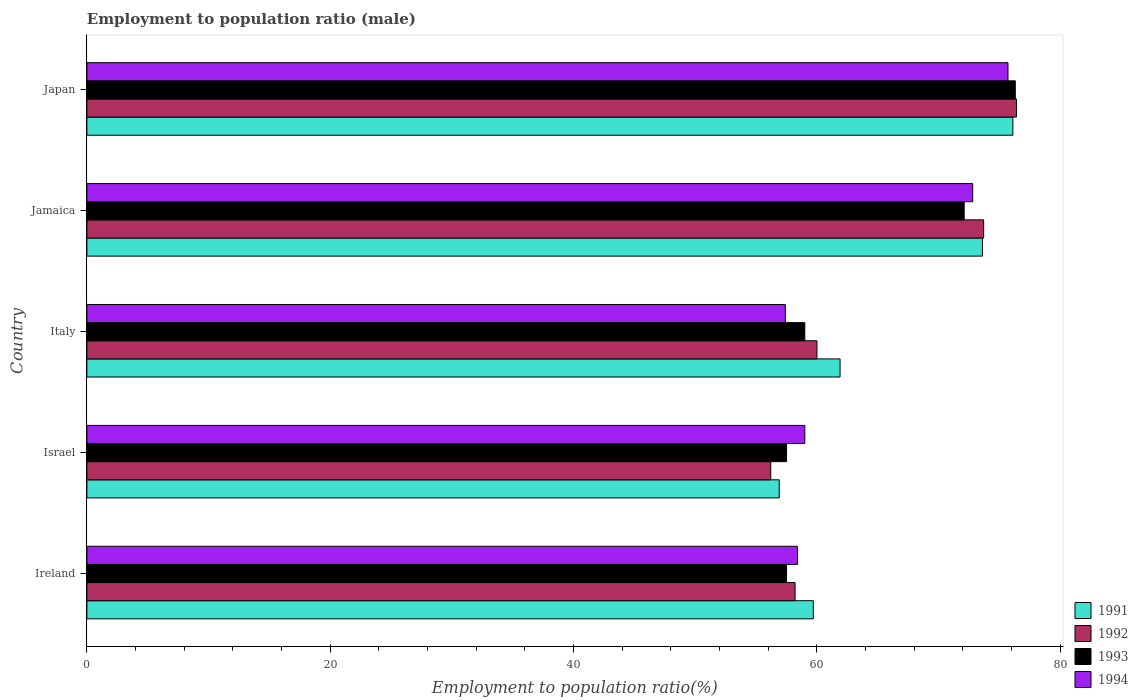How many different coloured bars are there?
Your answer should be compact. 4. How many groups of bars are there?
Offer a very short reply. 5. Are the number of bars on each tick of the Y-axis equal?
Give a very brief answer. Yes. What is the label of the 2nd group of bars from the top?
Provide a succinct answer. Jamaica. What is the employment to population ratio in 1991 in Ireland?
Provide a short and direct response. 59.7. Across all countries, what is the maximum employment to population ratio in 1994?
Offer a terse response. 75.7. Across all countries, what is the minimum employment to population ratio in 1992?
Your response must be concise. 56.2. In which country was the employment to population ratio in 1991 maximum?
Provide a short and direct response. Japan. What is the total employment to population ratio in 1992 in the graph?
Provide a succinct answer. 324.5. What is the difference between the employment to population ratio in 1991 in Ireland and that in Japan?
Your answer should be compact. -16.4. What is the average employment to population ratio in 1993 per country?
Keep it short and to the point. 64.48. What is the difference between the employment to population ratio in 1992 and employment to population ratio in 1993 in Jamaica?
Your response must be concise. 1.6. What is the ratio of the employment to population ratio in 1993 in Israel to that in Italy?
Your response must be concise. 0.97. What is the difference between the highest and the second highest employment to population ratio in 1993?
Give a very brief answer. 4.2. What is the difference between the highest and the lowest employment to population ratio in 1993?
Your answer should be compact. 18.8. Is it the case that in every country, the sum of the employment to population ratio in 1991 and employment to population ratio in 1992 is greater than the sum of employment to population ratio in 1994 and employment to population ratio in 1993?
Make the answer very short. No. What does the 3rd bar from the top in Japan represents?
Provide a short and direct response. 1992. How many countries are there in the graph?
Provide a succinct answer. 5. Does the graph contain any zero values?
Keep it short and to the point. No. Where does the legend appear in the graph?
Offer a terse response. Bottom right. How are the legend labels stacked?
Provide a succinct answer. Vertical. What is the title of the graph?
Provide a succinct answer. Employment to population ratio (male). What is the label or title of the X-axis?
Provide a succinct answer. Employment to population ratio(%). What is the label or title of the Y-axis?
Your answer should be compact. Country. What is the Employment to population ratio(%) in 1991 in Ireland?
Offer a very short reply. 59.7. What is the Employment to population ratio(%) in 1992 in Ireland?
Provide a succinct answer. 58.2. What is the Employment to population ratio(%) in 1993 in Ireland?
Offer a terse response. 57.5. What is the Employment to population ratio(%) in 1994 in Ireland?
Make the answer very short. 58.4. What is the Employment to population ratio(%) in 1991 in Israel?
Offer a very short reply. 56.9. What is the Employment to population ratio(%) of 1992 in Israel?
Your answer should be very brief. 56.2. What is the Employment to population ratio(%) of 1993 in Israel?
Your answer should be very brief. 57.5. What is the Employment to population ratio(%) of 1991 in Italy?
Your answer should be compact. 61.9. What is the Employment to population ratio(%) of 1993 in Italy?
Make the answer very short. 59. What is the Employment to population ratio(%) of 1994 in Italy?
Keep it short and to the point. 57.4. What is the Employment to population ratio(%) of 1991 in Jamaica?
Your answer should be very brief. 73.6. What is the Employment to population ratio(%) of 1992 in Jamaica?
Keep it short and to the point. 73.7. What is the Employment to population ratio(%) in 1993 in Jamaica?
Ensure brevity in your answer.  72.1. What is the Employment to population ratio(%) in 1994 in Jamaica?
Your answer should be compact. 72.8. What is the Employment to population ratio(%) of 1991 in Japan?
Provide a short and direct response. 76.1. What is the Employment to population ratio(%) of 1992 in Japan?
Offer a very short reply. 76.4. What is the Employment to population ratio(%) in 1993 in Japan?
Provide a succinct answer. 76.3. What is the Employment to population ratio(%) of 1994 in Japan?
Offer a terse response. 75.7. Across all countries, what is the maximum Employment to population ratio(%) of 1991?
Your answer should be very brief. 76.1. Across all countries, what is the maximum Employment to population ratio(%) in 1992?
Offer a very short reply. 76.4. Across all countries, what is the maximum Employment to population ratio(%) in 1993?
Provide a short and direct response. 76.3. Across all countries, what is the maximum Employment to population ratio(%) of 1994?
Offer a very short reply. 75.7. Across all countries, what is the minimum Employment to population ratio(%) of 1991?
Provide a short and direct response. 56.9. Across all countries, what is the minimum Employment to population ratio(%) in 1992?
Keep it short and to the point. 56.2. Across all countries, what is the minimum Employment to population ratio(%) in 1993?
Your answer should be very brief. 57.5. Across all countries, what is the minimum Employment to population ratio(%) of 1994?
Make the answer very short. 57.4. What is the total Employment to population ratio(%) of 1991 in the graph?
Offer a very short reply. 328.2. What is the total Employment to population ratio(%) of 1992 in the graph?
Give a very brief answer. 324.5. What is the total Employment to population ratio(%) of 1993 in the graph?
Make the answer very short. 322.4. What is the total Employment to population ratio(%) in 1994 in the graph?
Ensure brevity in your answer.  323.3. What is the difference between the Employment to population ratio(%) of 1993 in Ireland and that in Israel?
Your answer should be compact. 0. What is the difference between the Employment to population ratio(%) in 1994 in Ireland and that in Israel?
Offer a very short reply. -0.6. What is the difference between the Employment to population ratio(%) in 1991 in Ireland and that in Italy?
Your answer should be compact. -2.2. What is the difference between the Employment to population ratio(%) in 1992 in Ireland and that in Italy?
Make the answer very short. -1.8. What is the difference between the Employment to population ratio(%) in 1993 in Ireland and that in Italy?
Ensure brevity in your answer.  -1.5. What is the difference between the Employment to population ratio(%) in 1992 in Ireland and that in Jamaica?
Your answer should be compact. -15.5. What is the difference between the Employment to population ratio(%) of 1993 in Ireland and that in Jamaica?
Your answer should be very brief. -14.6. What is the difference between the Employment to population ratio(%) of 1994 in Ireland and that in Jamaica?
Offer a terse response. -14.4. What is the difference between the Employment to population ratio(%) in 1991 in Ireland and that in Japan?
Give a very brief answer. -16.4. What is the difference between the Employment to population ratio(%) of 1992 in Ireland and that in Japan?
Offer a very short reply. -18.2. What is the difference between the Employment to population ratio(%) in 1993 in Ireland and that in Japan?
Your response must be concise. -18.8. What is the difference between the Employment to population ratio(%) of 1994 in Ireland and that in Japan?
Offer a very short reply. -17.3. What is the difference between the Employment to population ratio(%) in 1993 in Israel and that in Italy?
Offer a very short reply. -1.5. What is the difference between the Employment to population ratio(%) of 1994 in Israel and that in Italy?
Your response must be concise. 1.6. What is the difference between the Employment to population ratio(%) of 1991 in Israel and that in Jamaica?
Offer a very short reply. -16.7. What is the difference between the Employment to population ratio(%) of 1992 in Israel and that in Jamaica?
Provide a succinct answer. -17.5. What is the difference between the Employment to population ratio(%) in 1993 in Israel and that in Jamaica?
Provide a succinct answer. -14.6. What is the difference between the Employment to population ratio(%) of 1994 in Israel and that in Jamaica?
Your answer should be very brief. -13.8. What is the difference between the Employment to population ratio(%) of 1991 in Israel and that in Japan?
Provide a succinct answer. -19.2. What is the difference between the Employment to population ratio(%) in 1992 in Israel and that in Japan?
Offer a very short reply. -20.2. What is the difference between the Employment to population ratio(%) in 1993 in Israel and that in Japan?
Your answer should be very brief. -18.8. What is the difference between the Employment to population ratio(%) of 1994 in Israel and that in Japan?
Provide a succinct answer. -16.7. What is the difference between the Employment to population ratio(%) in 1991 in Italy and that in Jamaica?
Your answer should be compact. -11.7. What is the difference between the Employment to population ratio(%) in 1992 in Italy and that in Jamaica?
Provide a succinct answer. -13.7. What is the difference between the Employment to population ratio(%) in 1994 in Italy and that in Jamaica?
Offer a terse response. -15.4. What is the difference between the Employment to population ratio(%) in 1991 in Italy and that in Japan?
Ensure brevity in your answer.  -14.2. What is the difference between the Employment to population ratio(%) of 1992 in Italy and that in Japan?
Offer a very short reply. -16.4. What is the difference between the Employment to population ratio(%) in 1993 in Italy and that in Japan?
Provide a short and direct response. -17.3. What is the difference between the Employment to population ratio(%) of 1994 in Italy and that in Japan?
Offer a very short reply. -18.3. What is the difference between the Employment to population ratio(%) in 1991 in Jamaica and that in Japan?
Give a very brief answer. -2.5. What is the difference between the Employment to population ratio(%) of 1992 in Jamaica and that in Japan?
Your answer should be compact. -2.7. What is the difference between the Employment to population ratio(%) in 1991 in Ireland and the Employment to population ratio(%) in 1992 in Israel?
Your response must be concise. 3.5. What is the difference between the Employment to population ratio(%) of 1991 in Ireland and the Employment to population ratio(%) of 1994 in Israel?
Offer a very short reply. 0.7. What is the difference between the Employment to population ratio(%) of 1993 in Ireland and the Employment to population ratio(%) of 1994 in Israel?
Keep it short and to the point. -1.5. What is the difference between the Employment to population ratio(%) of 1991 in Ireland and the Employment to population ratio(%) of 1994 in Italy?
Give a very brief answer. 2.3. What is the difference between the Employment to population ratio(%) of 1992 in Ireland and the Employment to population ratio(%) of 1994 in Italy?
Your answer should be very brief. 0.8. What is the difference between the Employment to population ratio(%) in 1991 in Ireland and the Employment to population ratio(%) in 1992 in Jamaica?
Give a very brief answer. -14. What is the difference between the Employment to population ratio(%) of 1991 in Ireland and the Employment to population ratio(%) of 1993 in Jamaica?
Your response must be concise. -12.4. What is the difference between the Employment to population ratio(%) of 1991 in Ireland and the Employment to population ratio(%) of 1994 in Jamaica?
Keep it short and to the point. -13.1. What is the difference between the Employment to population ratio(%) of 1992 in Ireland and the Employment to population ratio(%) of 1994 in Jamaica?
Offer a terse response. -14.6. What is the difference between the Employment to population ratio(%) in 1993 in Ireland and the Employment to population ratio(%) in 1994 in Jamaica?
Your answer should be compact. -15.3. What is the difference between the Employment to population ratio(%) of 1991 in Ireland and the Employment to population ratio(%) of 1992 in Japan?
Your answer should be very brief. -16.7. What is the difference between the Employment to population ratio(%) in 1991 in Ireland and the Employment to population ratio(%) in 1993 in Japan?
Offer a terse response. -16.6. What is the difference between the Employment to population ratio(%) in 1992 in Ireland and the Employment to population ratio(%) in 1993 in Japan?
Your answer should be very brief. -18.1. What is the difference between the Employment to population ratio(%) of 1992 in Ireland and the Employment to population ratio(%) of 1994 in Japan?
Your answer should be compact. -17.5. What is the difference between the Employment to population ratio(%) of 1993 in Ireland and the Employment to population ratio(%) of 1994 in Japan?
Your answer should be very brief. -18.2. What is the difference between the Employment to population ratio(%) in 1991 in Israel and the Employment to population ratio(%) in 1992 in Italy?
Offer a terse response. -3.1. What is the difference between the Employment to population ratio(%) of 1991 in Israel and the Employment to population ratio(%) of 1994 in Italy?
Offer a terse response. -0.5. What is the difference between the Employment to population ratio(%) of 1992 in Israel and the Employment to population ratio(%) of 1993 in Italy?
Make the answer very short. -2.8. What is the difference between the Employment to population ratio(%) of 1992 in Israel and the Employment to population ratio(%) of 1994 in Italy?
Ensure brevity in your answer.  -1.2. What is the difference between the Employment to population ratio(%) of 1993 in Israel and the Employment to population ratio(%) of 1994 in Italy?
Your answer should be compact. 0.1. What is the difference between the Employment to population ratio(%) of 1991 in Israel and the Employment to population ratio(%) of 1992 in Jamaica?
Give a very brief answer. -16.8. What is the difference between the Employment to population ratio(%) in 1991 in Israel and the Employment to population ratio(%) in 1993 in Jamaica?
Your answer should be compact. -15.2. What is the difference between the Employment to population ratio(%) in 1991 in Israel and the Employment to population ratio(%) in 1994 in Jamaica?
Your response must be concise. -15.9. What is the difference between the Employment to population ratio(%) of 1992 in Israel and the Employment to population ratio(%) of 1993 in Jamaica?
Give a very brief answer. -15.9. What is the difference between the Employment to population ratio(%) in 1992 in Israel and the Employment to population ratio(%) in 1994 in Jamaica?
Keep it short and to the point. -16.6. What is the difference between the Employment to population ratio(%) in 1993 in Israel and the Employment to population ratio(%) in 1994 in Jamaica?
Give a very brief answer. -15.3. What is the difference between the Employment to population ratio(%) of 1991 in Israel and the Employment to population ratio(%) of 1992 in Japan?
Offer a very short reply. -19.5. What is the difference between the Employment to population ratio(%) of 1991 in Israel and the Employment to population ratio(%) of 1993 in Japan?
Make the answer very short. -19.4. What is the difference between the Employment to population ratio(%) of 1991 in Israel and the Employment to population ratio(%) of 1994 in Japan?
Make the answer very short. -18.8. What is the difference between the Employment to population ratio(%) in 1992 in Israel and the Employment to population ratio(%) in 1993 in Japan?
Ensure brevity in your answer.  -20.1. What is the difference between the Employment to population ratio(%) in 1992 in Israel and the Employment to population ratio(%) in 1994 in Japan?
Provide a succinct answer. -19.5. What is the difference between the Employment to population ratio(%) of 1993 in Israel and the Employment to population ratio(%) of 1994 in Japan?
Your answer should be very brief. -18.2. What is the difference between the Employment to population ratio(%) in 1991 in Italy and the Employment to population ratio(%) in 1992 in Jamaica?
Make the answer very short. -11.8. What is the difference between the Employment to population ratio(%) of 1991 in Italy and the Employment to population ratio(%) of 1994 in Jamaica?
Ensure brevity in your answer.  -10.9. What is the difference between the Employment to population ratio(%) of 1992 in Italy and the Employment to population ratio(%) of 1994 in Jamaica?
Provide a succinct answer. -12.8. What is the difference between the Employment to population ratio(%) of 1993 in Italy and the Employment to population ratio(%) of 1994 in Jamaica?
Give a very brief answer. -13.8. What is the difference between the Employment to population ratio(%) in 1991 in Italy and the Employment to population ratio(%) in 1993 in Japan?
Your answer should be compact. -14.4. What is the difference between the Employment to population ratio(%) in 1992 in Italy and the Employment to population ratio(%) in 1993 in Japan?
Offer a terse response. -16.3. What is the difference between the Employment to population ratio(%) of 1992 in Italy and the Employment to population ratio(%) of 1994 in Japan?
Provide a succinct answer. -15.7. What is the difference between the Employment to population ratio(%) of 1993 in Italy and the Employment to population ratio(%) of 1994 in Japan?
Provide a succinct answer. -16.7. What is the difference between the Employment to population ratio(%) in 1991 in Jamaica and the Employment to population ratio(%) in 1992 in Japan?
Your answer should be very brief. -2.8. What is the difference between the Employment to population ratio(%) of 1991 in Jamaica and the Employment to population ratio(%) of 1993 in Japan?
Your answer should be compact. -2.7. What is the difference between the Employment to population ratio(%) of 1991 in Jamaica and the Employment to population ratio(%) of 1994 in Japan?
Your response must be concise. -2.1. What is the difference between the Employment to population ratio(%) of 1992 in Jamaica and the Employment to population ratio(%) of 1994 in Japan?
Give a very brief answer. -2. What is the average Employment to population ratio(%) of 1991 per country?
Make the answer very short. 65.64. What is the average Employment to population ratio(%) of 1992 per country?
Offer a very short reply. 64.9. What is the average Employment to population ratio(%) in 1993 per country?
Offer a very short reply. 64.48. What is the average Employment to population ratio(%) in 1994 per country?
Give a very brief answer. 64.66. What is the difference between the Employment to population ratio(%) in 1991 and Employment to population ratio(%) in 1992 in Ireland?
Offer a very short reply. 1.5. What is the difference between the Employment to population ratio(%) in 1991 and Employment to population ratio(%) in 1993 in Ireland?
Offer a very short reply. 2.2. What is the difference between the Employment to population ratio(%) in 1992 and Employment to population ratio(%) in 1993 in Ireland?
Make the answer very short. 0.7. What is the difference between the Employment to population ratio(%) in 1992 and Employment to population ratio(%) in 1994 in Ireland?
Keep it short and to the point. -0.2. What is the difference between the Employment to population ratio(%) in 1991 and Employment to population ratio(%) in 1993 in Israel?
Your answer should be very brief. -0.6. What is the difference between the Employment to population ratio(%) of 1992 and Employment to population ratio(%) of 1994 in Israel?
Provide a short and direct response. -2.8. What is the difference between the Employment to population ratio(%) in 1993 and Employment to population ratio(%) in 1994 in Israel?
Offer a terse response. -1.5. What is the difference between the Employment to population ratio(%) in 1991 and Employment to population ratio(%) in 1992 in Italy?
Keep it short and to the point. 1.9. What is the difference between the Employment to population ratio(%) of 1991 and Employment to population ratio(%) of 1993 in Italy?
Offer a terse response. 2.9. What is the difference between the Employment to population ratio(%) of 1992 and Employment to population ratio(%) of 1994 in Italy?
Ensure brevity in your answer.  2.6. What is the difference between the Employment to population ratio(%) of 1991 and Employment to population ratio(%) of 1992 in Jamaica?
Ensure brevity in your answer.  -0.1. What is the difference between the Employment to population ratio(%) in 1991 and Employment to population ratio(%) in 1994 in Jamaica?
Provide a short and direct response. 0.8. What is the difference between the Employment to population ratio(%) of 1992 and Employment to population ratio(%) of 1993 in Jamaica?
Offer a very short reply. 1.6. What is the difference between the Employment to population ratio(%) in 1992 and Employment to population ratio(%) in 1994 in Jamaica?
Your answer should be very brief. 0.9. What is the difference between the Employment to population ratio(%) of 1993 and Employment to population ratio(%) of 1994 in Jamaica?
Give a very brief answer. -0.7. What is the difference between the Employment to population ratio(%) of 1991 and Employment to population ratio(%) of 1993 in Japan?
Give a very brief answer. -0.2. What is the difference between the Employment to population ratio(%) in 1992 and Employment to population ratio(%) in 1993 in Japan?
Ensure brevity in your answer.  0.1. What is the ratio of the Employment to population ratio(%) of 1991 in Ireland to that in Israel?
Provide a succinct answer. 1.05. What is the ratio of the Employment to population ratio(%) of 1992 in Ireland to that in Israel?
Ensure brevity in your answer.  1.04. What is the ratio of the Employment to population ratio(%) in 1991 in Ireland to that in Italy?
Provide a short and direct response. 0.96. What is the ratio of the Employment to population ratio(%) in 1992 in Ireland to that in Italy?
Provide a succinct answer. 0.97. What is the ratio of the Employment to population ratio(%) in 1993 in Ireland to that in Italy?
Offer a terse response. 0.97. What is the ratio of the Employment to population ratio(%) of 1994 in Ireland to that in Italy?
Your response must be concise. 1.02. What is the ratio of the Employment to population ratio(%) in 1991 in Ireland to that in Jamaica?
Your answer should be very brief. 0.81. What is the ratio of the Employment to population ratio(%) in 1992 in Ireland to that in Jamaica?
Make the answer very short. 0.79. What is the ratio of the Employment to population ratio(%) in 1993 in Ireland to that in Jamaica?
Provide a short and direct response. 0.8. What is the ratio of the Employment to population ratio(%) in 1994 in Ireland to that in Jamaica?
Your answer should be very brief. 0.8. What is the ratio of the Employment to population ratio(%) in 1991 in Ireland to that in Japan?
Your answer should be very brief. 0.78. What is the ratio of the Employment to population ratio(%) of 1992 in Ireland to that in Japan?
Your answer should be very brief. 0.76. What is the ratio of the Employment to population ratio(%) of 1993 in Ireland to that in Japan?
Provide a succinct answer. 0.75. What is the ratio of the Employment to population ratio(%) of 1994 in Ireland to that in Japan?
Your answer should be very brief. 0.77. What is the ratio of the Employment to population ratio(%) in 1991 in Israel to that in Italy?
Make the answer very short. 0.92. What is the ratio of the Employment to population ratio(%) of 1992 in Israel to that in Italy?
Give a very brief answer. 0.94. What is the ratio of the Employment to population ratio(%) in 1993 in Israel to that in Italy?
Offer a very short reply. 0.97. What is the ratio of the Employment to population ratio(%) in 1994 in Israel to that in Italy?
Offer a very short reply. 1.03. What is the ratio of the Employment to population ratio(%) of 1991 in Israel to that in Jamaica?
Offer a terse response. 0.77. What is the ratio of the Employment to population ratio(%) in 1992 in Israel to that in Jamaica?
Ensure brevity in your answer.  0.76. What is the ratio of the Employment to population ratio(%) in 1993 in Israel to that in Jamaica?
Give a very brief answer. 0.8. What is the ratio of the Employment to population ratio(%) of 1994 in Israel to that in Jamaica?
Give a very brief answer. 0.81. What is the ratio of the Employment to population ratio(%) of 1991 in Israel to that in Japan?
Give a very brief answer. 0.75. What is the ratio of the Employment to population ratio(%) in 1992 in Israel to that in Japan?
Keep it short and to the point. 0.74. What is the ratio of the Employment to population ratio(%) in 1993 in Israel to that in Japan?
Ensure brevity in your answer.  0.75. What is the ratio of the Employment to population ratio(%) in 1994 in Israel to that in Japan?
Offer a terse response. 0.78. What is the ratio of the Employment to population ratio(%) of 1991 in Italy to that in Jamaica?
Keep it short and to the point. 0.84. What is the ratio of the Employment to population ratio(%) of 1992 in Italy to that in Jamaica?
Provide a short and direct response. 0.81. What is the ratio of the Employment to population ratio(%) of 1993 in Italy to that in Jamaica?
Your answer should be very brief. 0.82. What is the ratio of the Employment to population ratio(%) of 1994 in Italy to that in Jamaica?
Offer a terse response. 0.79. What is the ratio of the Employment to population ratio(%) in 1991 in Italy to that in Japan?
Your response must be concise. 0.81. What is the ratio of the Employment to population ratio(%) of 1992 in Italy to that in Japan?
Ensure brevity in your answer.  0.79. What is the ratio of the Employment to population ratio(%) of 1993 in Italy to that in Japan?
Provide a short and direct response. 0.77. What is the ratio of the Employment to population ratio(%) in 1994 in Italy to that in Japan?
Offer a very short reply. 0.76. What is the ratio of the Employment to population ratio(%) in 1991 in Jamaica to that in Japan?
Your response must be concise. 0.97. What is the ratio of the Employment to population ratio(%) in 1992 in Jamaica to that in Japan?
Keep it short and to the point. 0.96. What is the ratio of the Employment to population ratio(%) of 1993 in Jamaica to that in Japan?
Offer a terse response. 0.94. What is the ratio of the Employment to population ratio(%) of 1994 in Jamaica to that in Japan?
Offer a very short reply. 0.96. What is the difference between the highest and the second highest Employment to population ratio(%) of 1992?
Your response must be concise. 2.7. What is the difference between the highest and the second highest Employment to population ratio(%) of 1993?
Provide a succinct answer. 4.2. What is the difference between the highest and the second highest Employment to population ratio(%) of 1994?
Provide a succinct answer. 2.9. What is the difference between the highest and the lowest Employment to population ratio(%) in 1992?
Keep it short and to the point. 20.2. 